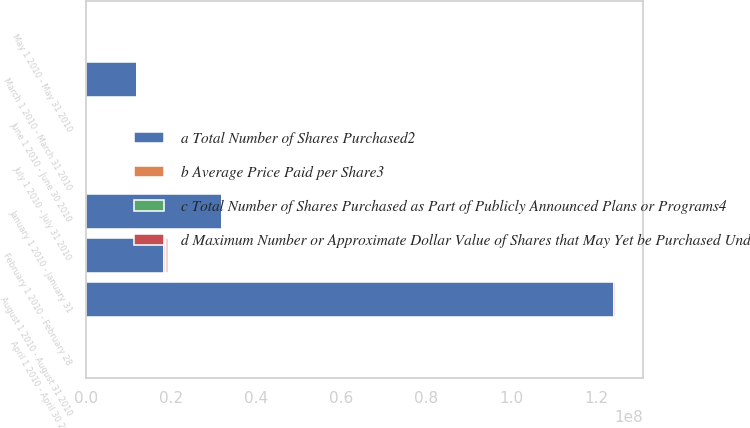Convert chart to OTSL. <chart><loc_0><loc_0><loc_500><loc_500><stacked_bar_chart><ecel><fcel>January 1 2010 - January 31<fcel>February 1 2010 - February 28<fcel>March 1 2010 - March 31 2010<fcel>April 1 2010 - April 30 2010<fcel>May 1 2010 - May 31 2010<fcel>June 1 2010 - June 30 2010<fcel>July 1 2010 - July 31 2010<fcel>August 1 2010 - August 31 2010<nl><fcel>b Average Price Paid per Share3<fcel>71900<fcel>547220<fcel>215000<fcel>160970<fcel>209800<fcel>166155<fcel>116650<fcel>291700<nl><fcel>c Total Number of Shares Purchased as Part of Publicly Announced Plans or Programs4<fcel>26.26<fcel>24.95<fcel>29.62<fcel>32.98<fcel>38.54<fcel>42.25<fcel>41.95<fcel>41.95<nl><fcel>d Maximum Number or Approximate Dollar Value of Shares that May Yet be Purchased Under Plans or Programs5<fcel>71900<fcel>547220<fcel>215000<fcel>160970<fcel>209800<fcel>166155<fcel>116650<fcel>291700<nl><fcel>a Total Number of Shares Purchased2<fcel>3.18107e+07<fcel>1.81602e+07<fcel>1.17916e+07<fcel>163562<fcel>163562<fcel>163562<fcel>163562<fcel>1.24248e+08<nl></chart> 